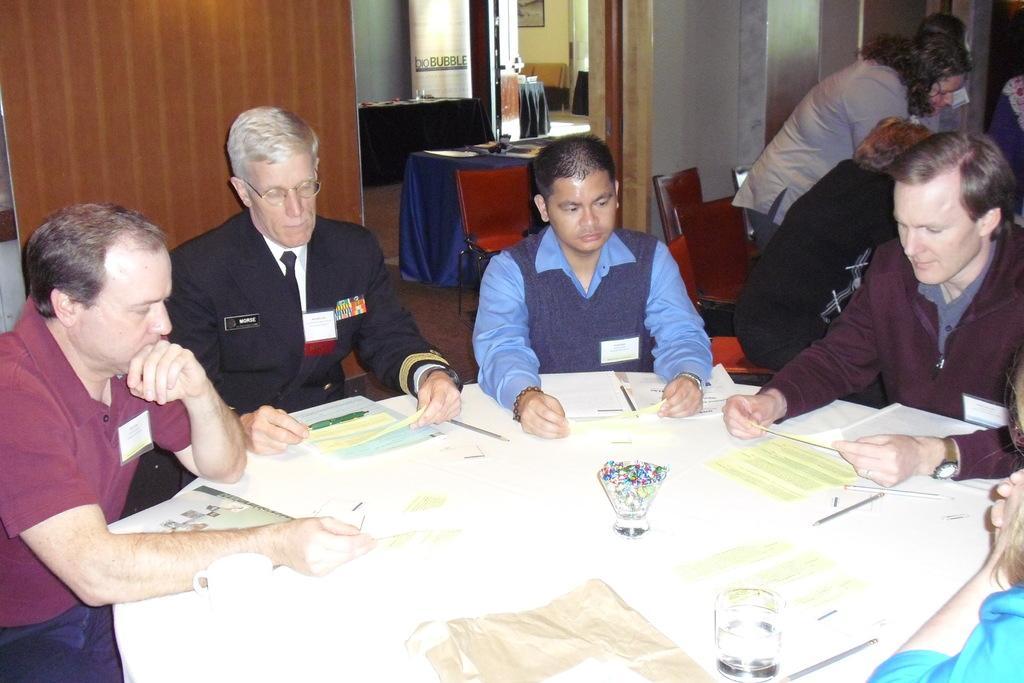Can you describe this image briefly? In this picture I can see a number of sitting chairs. I can see the tables. I can see a few people sitting. I can see glasses on the table. I can see a few people on the right side. 